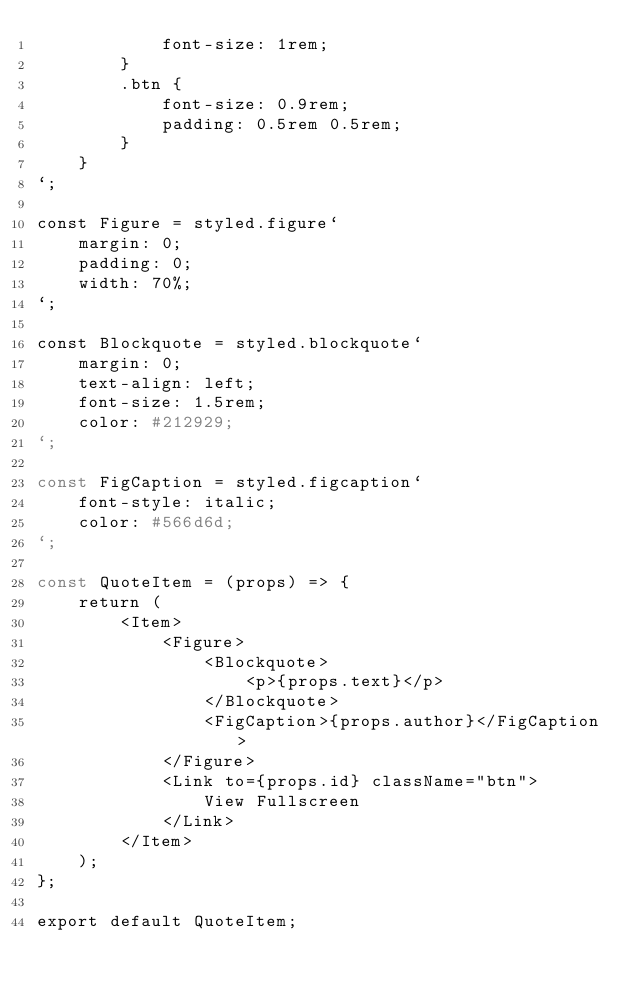Convert code to text. <code><loc_0><loc_0><loc_500><loc_500><_JavaScript_>            font-size: 1rem;
        }
        .btn {
            font-size: 0.9rem;
            padding: 0.5rem 0.5rem;
        }
    }
`;

const Figure = styled.figure`
    margin: 0;
    padding: 0;
    width: 70%;
`;

const Blockquote = styled.blockquote`
    margin: 0;
    text-align: left;
    font-size: 1.5rem;
    color: #212929;
`;

const FigCaption = styled.figcaption`
    font-style: italic;
    color: #566d6d;
`;

const QuoteItem = (props) => {
    return (
        <Item>
            <Figure>
                <Blockquote>
                    <p>{props.text}</p>
                </Blockquote>
                <FigCaption>{props.author}</FigCaption>
            </Figure>
            <Link to={props.id} className="btn">
                View Fullscreen
            </Link>
        </Item>
    );
};

export default QuoteItem;
</code> 